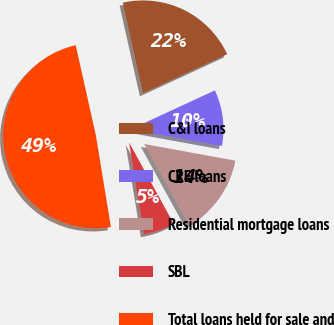Convert chart to OTSL. <chart><loc_0><loc_0><loc_500><loc_500><pie_chart><fcel>C&I loans<fcel>CRE loans<fcel>Residential mortgage loans<fcel>SBL<fcel>Total loans held for sale and<nl><fcel>21.6%<fcel>9.77%<fcel>14.14%<fcel>5.4%<fcel>49.09%<nl></chart> 